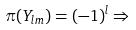<formula> <loc_0><loc_0><loc_500><loc_500>\pi ( Y _ { l m } ) = ( - 1 ) ^ { l } \Rightarrow</formula> 